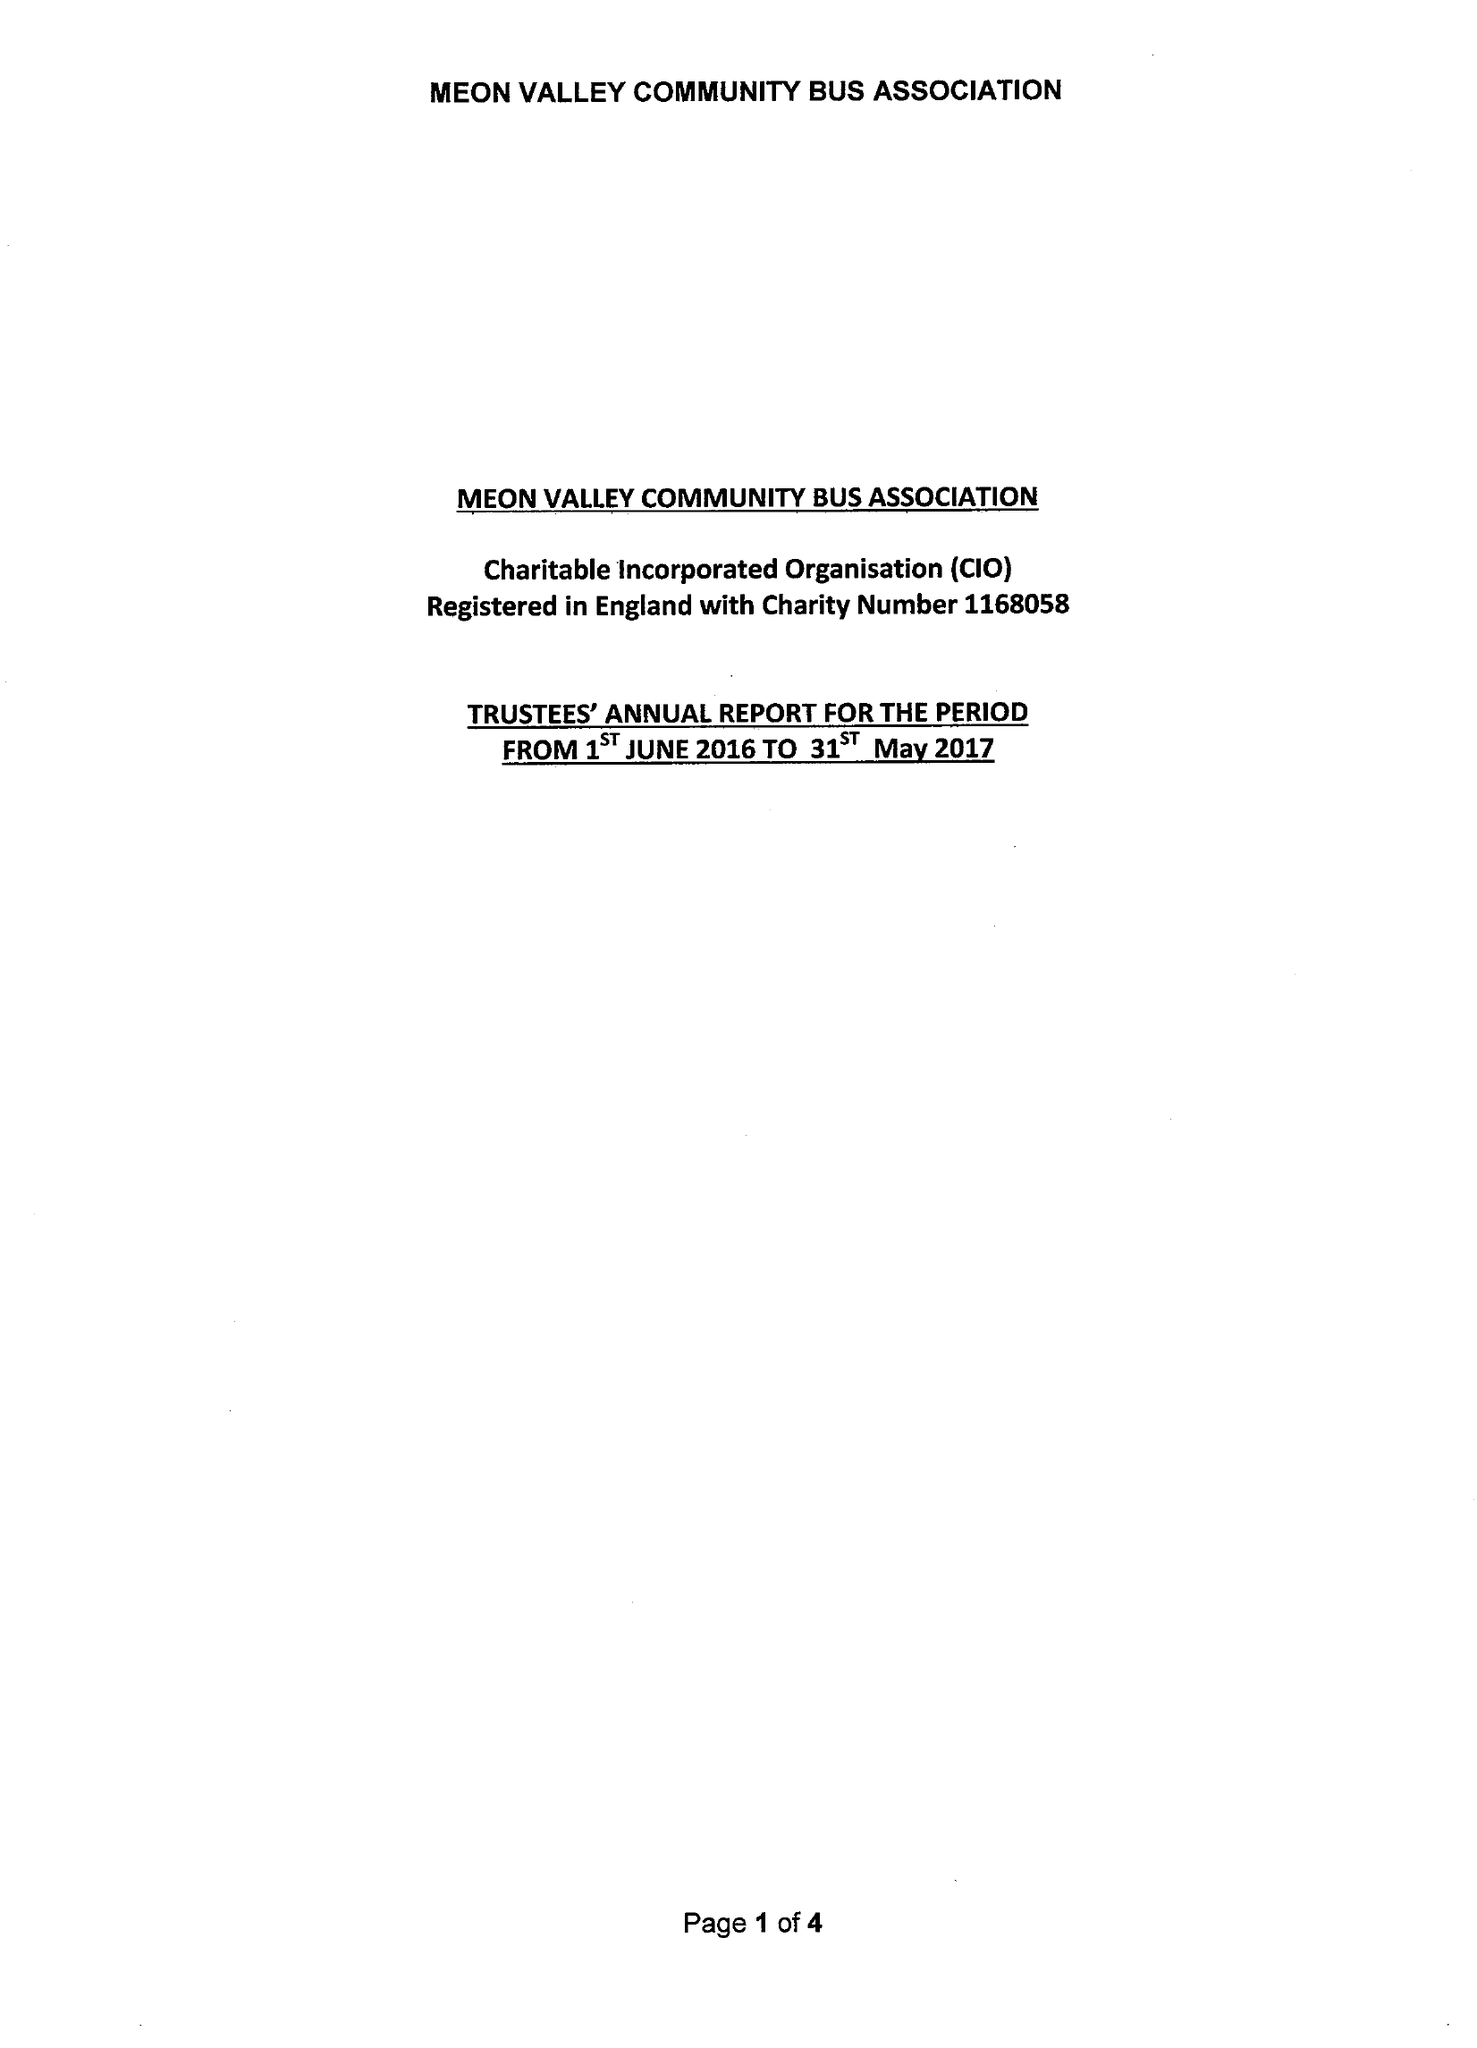What is the value for the address__street_line?
Answer the question using a single word or phrase. STATION ROAD 